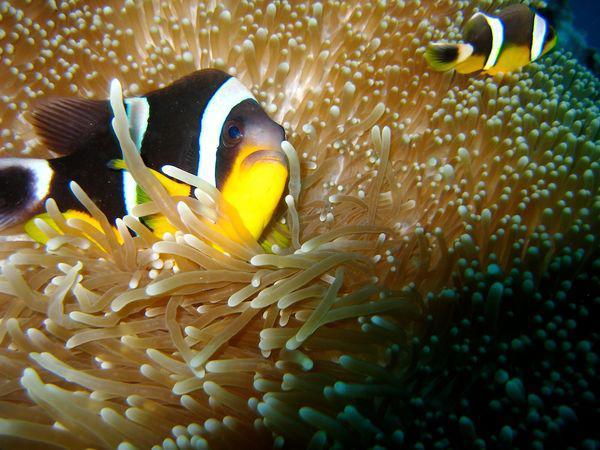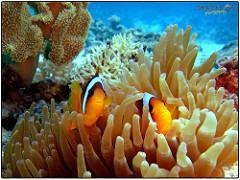The first image is the image on the left, the second image is the image on the right. For the images shown, is this caption "There is exactly one fish in both images." true? Answer yes or no. No. 